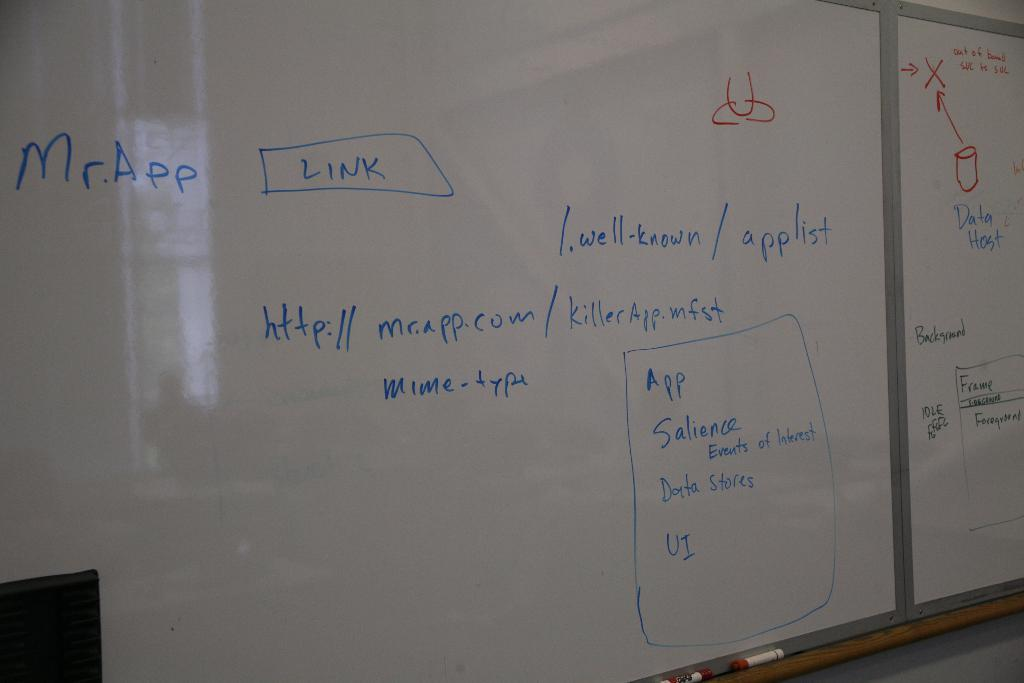<image>
Present a compact description of the photo's key features. a white board has the writing with Mr App link on it 